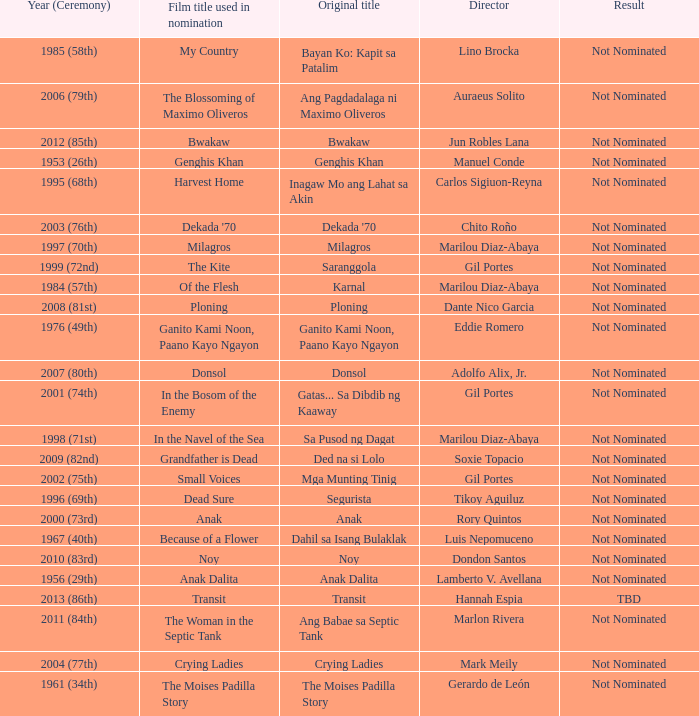What is the year when not nominated was the result, and In the Navel of the Sea was the film title used in nomination? 1998 (71st). 